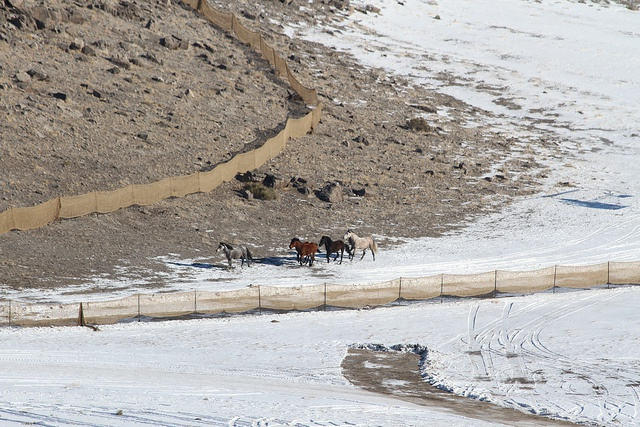Describe the objects in this image and their specific colors. I can see horse in gray, black, and darkgray tones, horse in gray, darkgray, and tan tones, horse in gray, black, and darkgray tones, and horse in gray, maroon, and black tones in this image. 